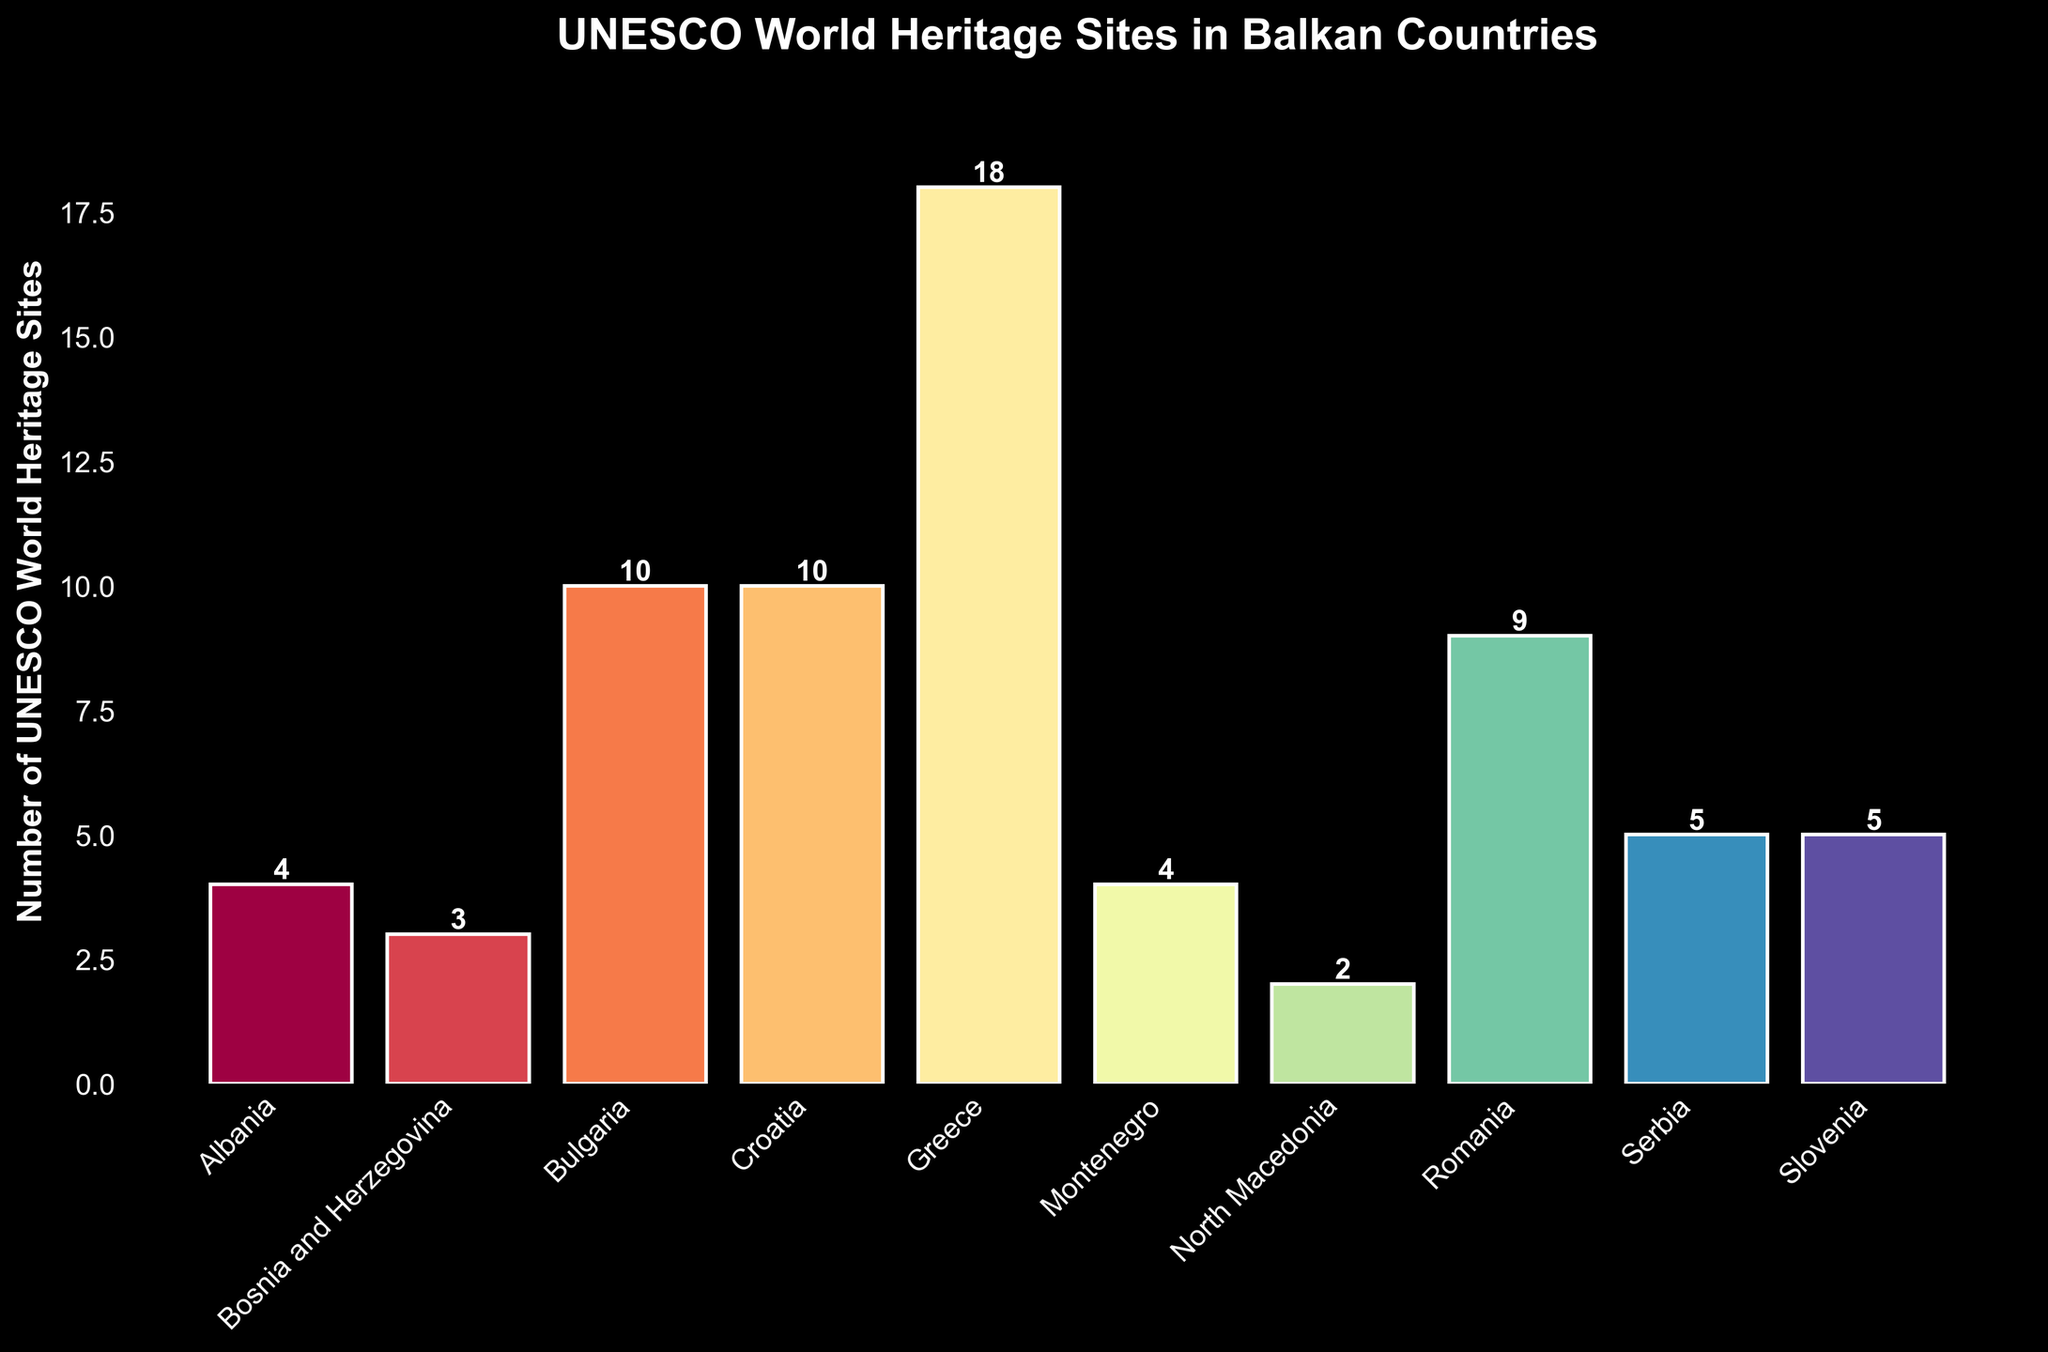Which country has the highest number of UNESCO World Heritage Sites? Look at the bar with the greatest height. Greece has the highest number of sites with a total of 18.
Answer: Greece Which two countries have the same number of UNESCO World Heritage Sites? Identify bars of equal height. Croatia and Bulgaria both have 10 sites each, and Serbia and Slovenia each have 5 sites.
Answer: Croatia and Bulgaria; Serbia and Slovenia What's the difference in the number of UNESCO World Heritage Sites between Greece and Bosnia and Herzegovina? Subtract the number of sites in Bosnia and Herzegovina from the number of sites in Greece. Greece has 18 and Bosnia and Herzegovina has 3, so 18 - 3 = 15.
Answer: 15 What is the sum of UNESCO World Heritage Sites in Montenegro and North Macedonia? Add the number of sites in Montenegro and North Macedonia. Montenegro has 4 and North Macedonia has 2, so 4 + 2 = 6.
Answer: 6 How many more UNESCO World Heritage Sites does Romania have compared to Albania? Subtract the number of sites in Albania from the number of sites in Romania. Romania has 9 and Albania has 4, so 9 - 4 = 5.
Answer: 5 What is the average number of UNESCO World Heritage Sites across all the listed Balkan countries? Sum up all the sites and divide by the number of countries. (4 + 3 + 10 + 10 + 18 + 4 + 2 + 9 + 5 + 5) / 10 = 70 / 10 = 7.
Answer: 7 Which countries have fewer than 5 UNESCO World Heritage Sites? Identify bars with a height less than 5. Bosnia and Herzegovina, North Macedonia, and Albania have fewer than 5 sites.
Answer: Bosnia and Herzegovina, North Macedonia, Albania What is the total number of UNESCO World Heritage Sites in countries with exactly 10 sites? Sum up the number of sites in Croatia and Bulgaria since they have exactly 10 sites each. 10 + 10 = 20.
Answer: 20 Which country has the shortest bar, and how many sites does it represent? Look for the bar with the smallest height. North Macedonia has the shortest bar representing 2 sites.
Answer: North Macedonia; 2 How many countries have more than the average number of UNESCO World Heritage Sites? The average number of sites is 7. Count the countries with more than 7 sites: Bulgaria (10), Croatia (10), Greece (18), and Romania (9). There are 4 such countries.
Answer: 4 